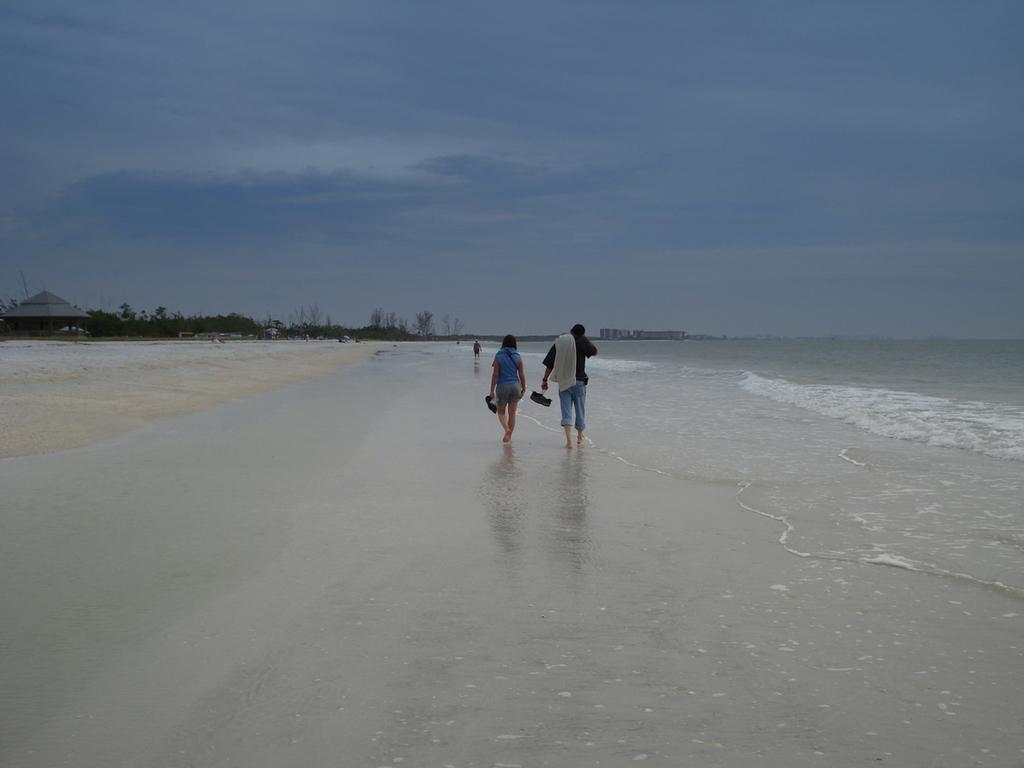Please provide a concise description of this image. In this picture I can see there is a man and woman walking along the beach and there is a ocean on the right side and there are trees on the left side. The sky is clear. 